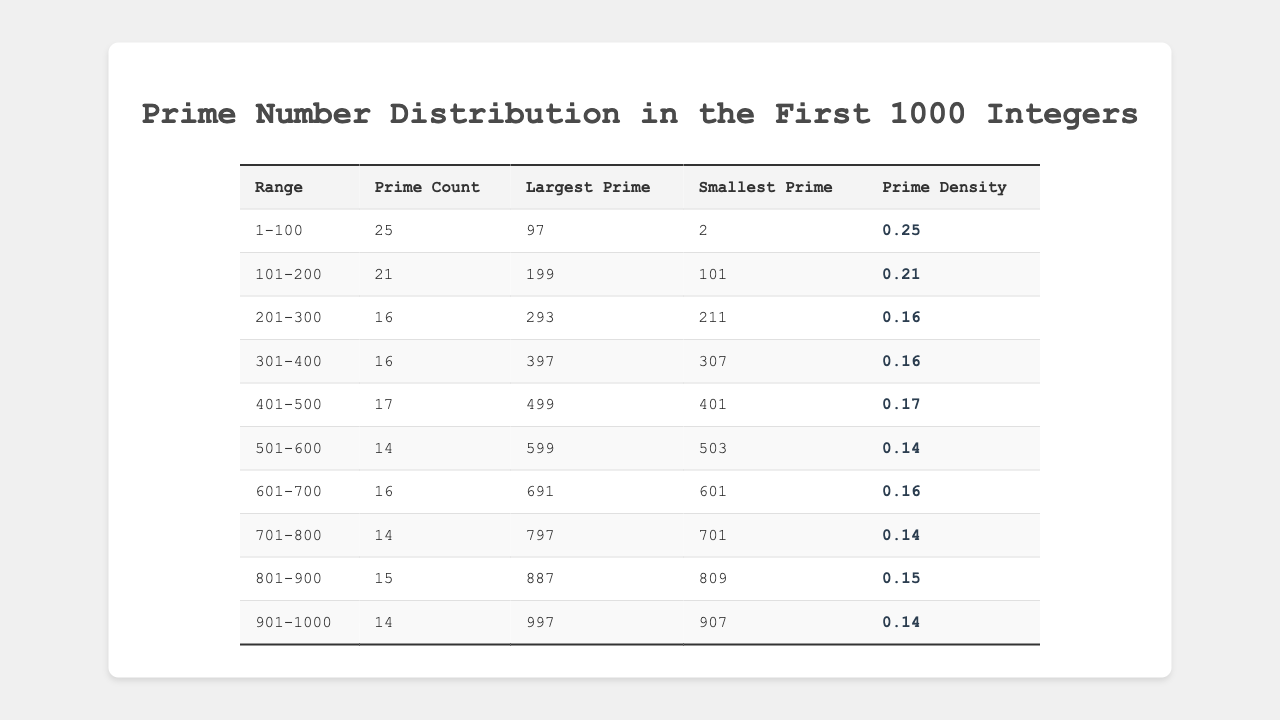what is the prime count for the range 101-200? The table entry for the range 101-200 indicates that there are 21 prime numbers.
Answer: 21 what is the largest prime number in the range 401-500? Referring to the table, the largest prime in the 401-500 range is listed as 499.
Answer: 499 how many primes are there in the range 701-800? In the range 701-800, the table shows there are 14 prime numbers.
Answer: 14 what is the smallest prime number listed in the range 801-900? According to the table, the smallest prime in the range 801-900 is 809.
Answer: 809 what is the average prime density of all ranges combined? To find the average prime density, sum the densities (0.25 + 0.21 + 0.16 + 0.16 + 0.17 + 0.14 + 0.16 + 0.14 + 0.15 + 0.14 = 1.65) and divide by the number of ranges (10). Thus, the average is 1.65 / 10 = 0.165.
Answer: 0.165 is there a decrease in the number of primes from the range 1-100 to 101-200? Comparing the two ranges, 1-100 has 25 primes while 101-200 has 21 primes, showing a decrease of 4.
Answer: Yes how many primes are there in total from ranges 1-100 and 901-1000 combined? The total prime count from 1-100 is 25 and from 901-1000 is 14. Adding these, 25 + 14 = 39 gives the total number of primes in these ranges.
Answer: 39 which range has the highest prime density? Reviewing the prime densities, the range 1-100 has the highest density at 0.25.
Answer: 1-100 what is the difference in the prime count between the ranges 201-300 and 301-400? The prime count in 201-300 is 16, and in 301-400 it is also 16. Therefore, the difference is 16 - 16 = 0.
Answer: 0 are there more primes in the range 501-600 or 701-800? The range 501-600 has 14 primes, while 701-800 also has 14 primes, indicating they are equal.
Answer: No, they are equal 